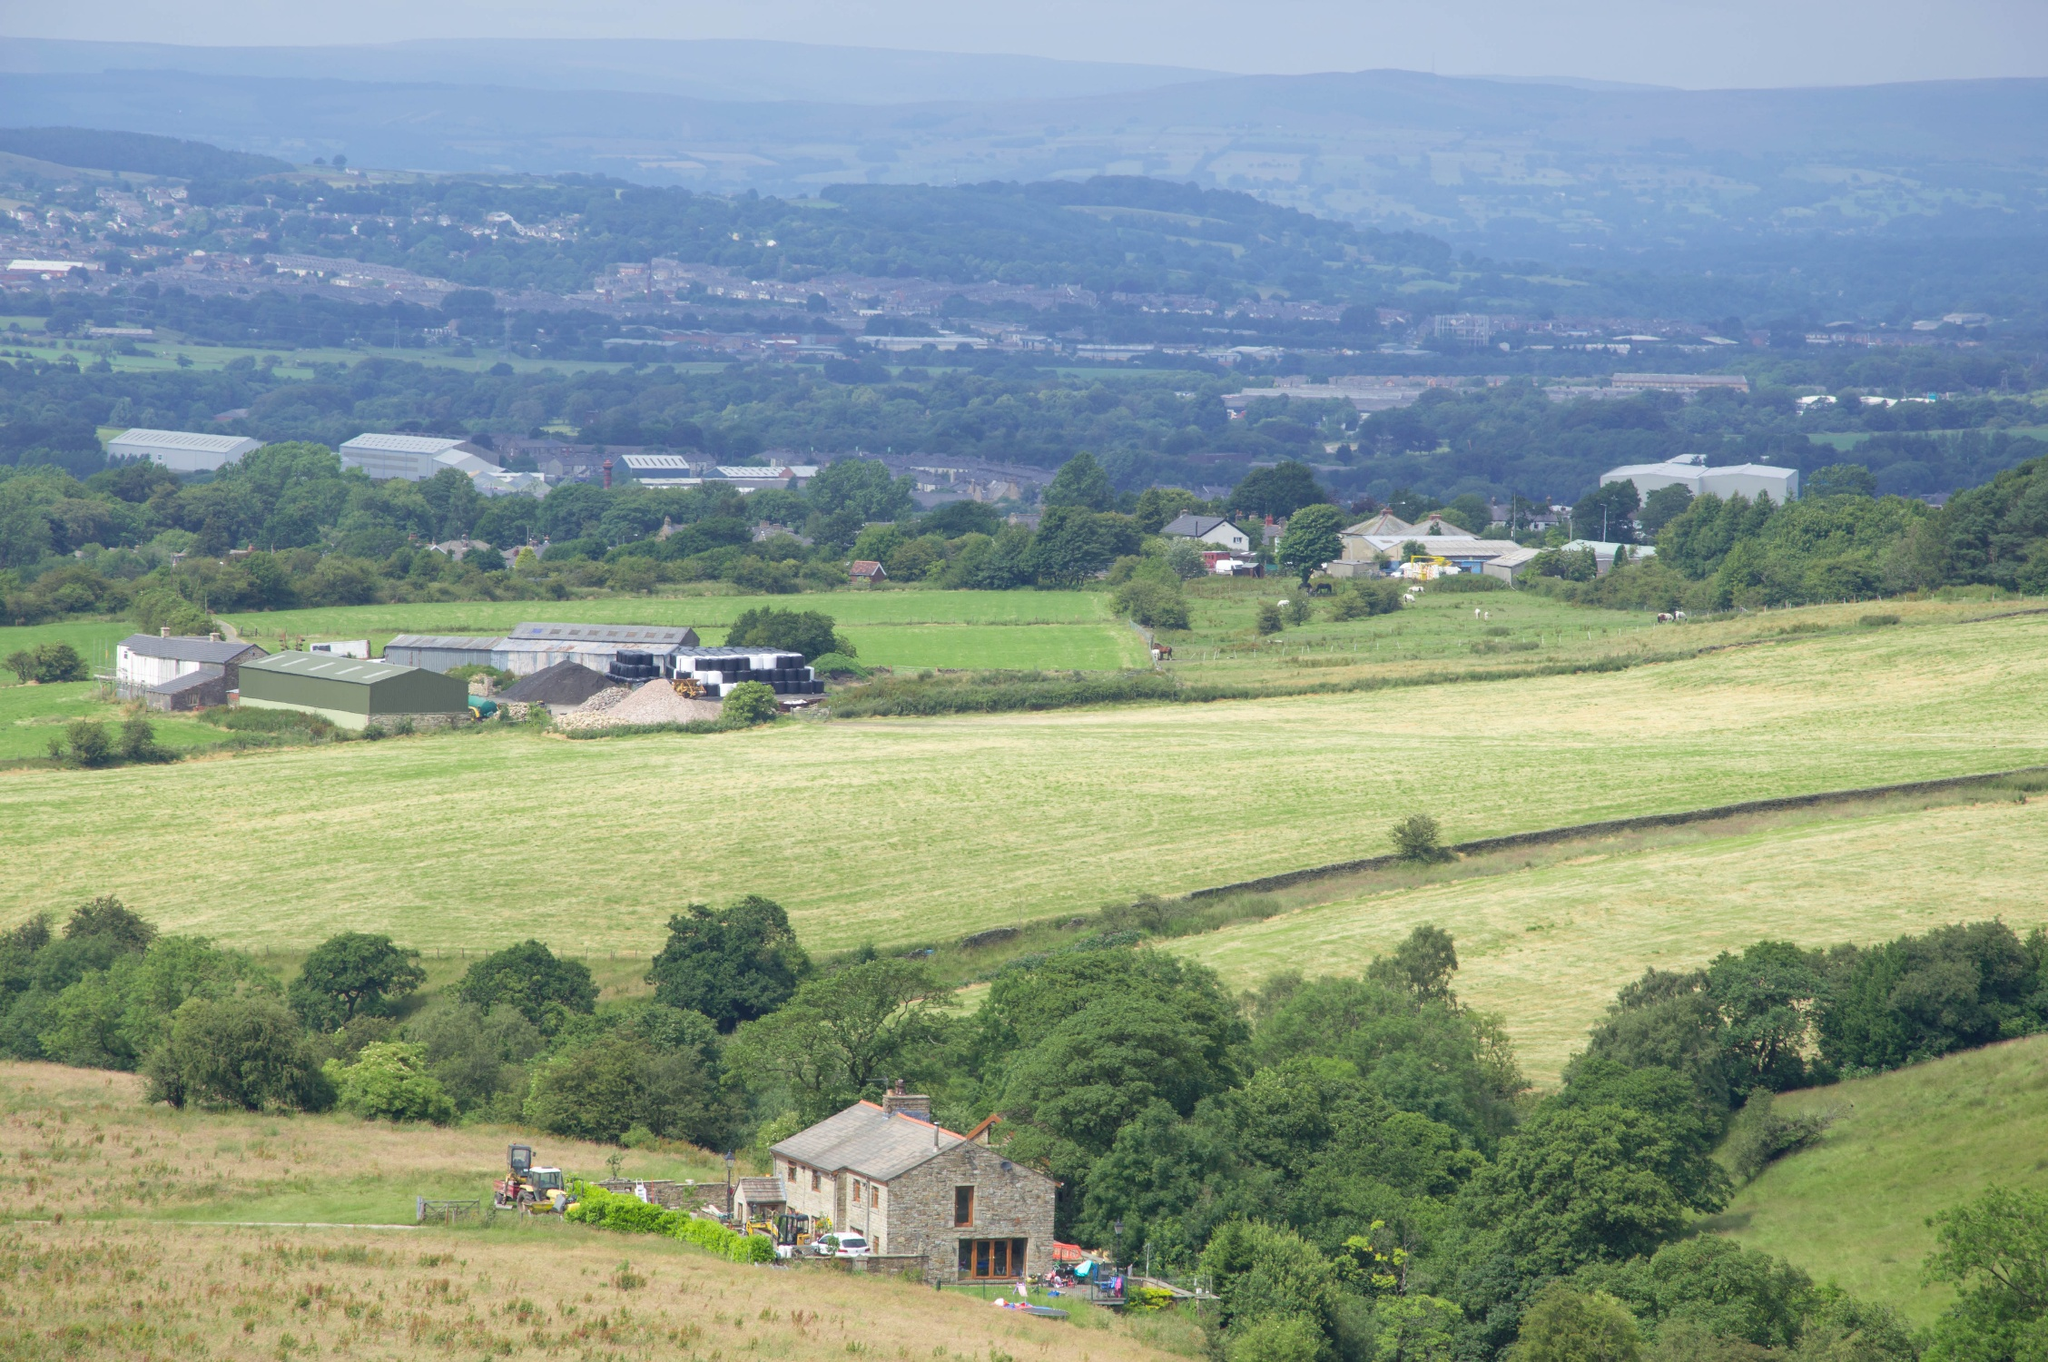What does this image tell us about the local community's lifestyle? The image suggests a rural, community-focused lifestyle, likely with a strong connection to agriculture. The scattered layout of the village implies that it's a small, closely-knit community where farming plays a central role in their daily lives and local economy. The presence of small but substantial buildings and well-maintained fields indicate a balance between traditional practices and modern farming techniques. The overall tranquility and natural beauty of the area likely also contributes to a leisurely pace of life, with strong ties to the surrounding natural environment. 